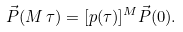Convert formula to latex. <formula><loc_0><loc_0><loc_500><loc_500>\vec { P } ( M \, \tau ) = [ p ( \tau ) ] ^ { M } \vec { P } ( 0 ) .</formula> 